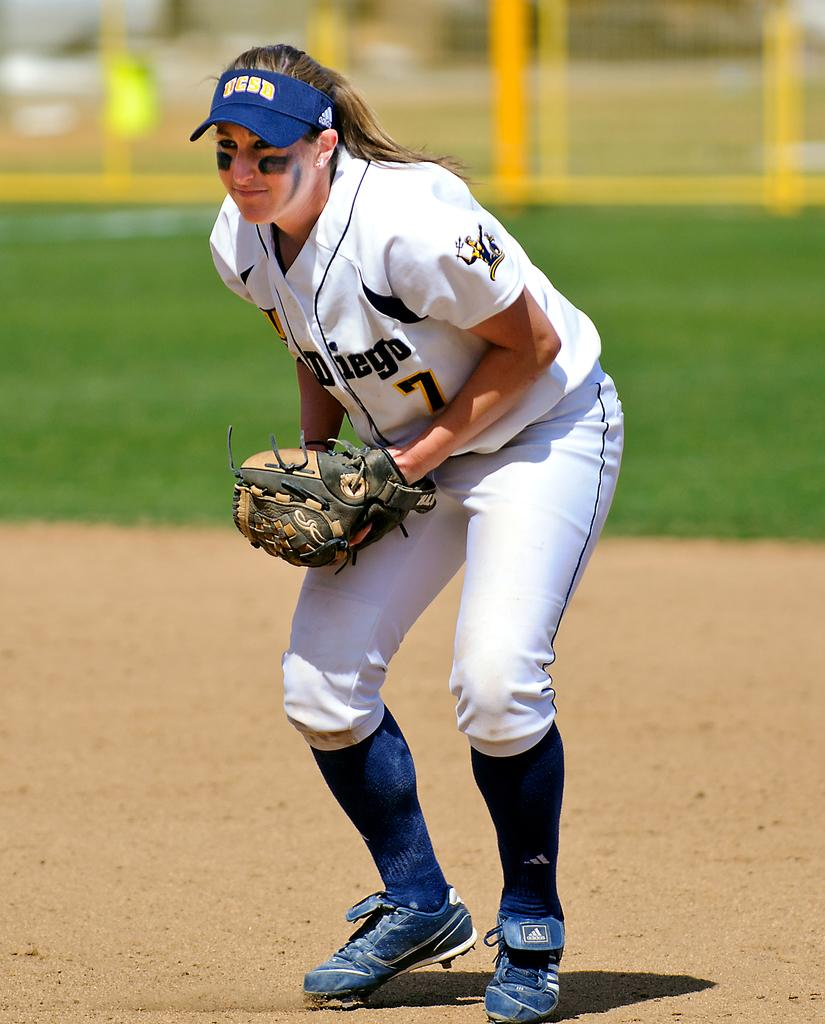<image>
Create a compact narrative representing the image presented. A girl is wearing a softball uniform with the number 7 on it. 